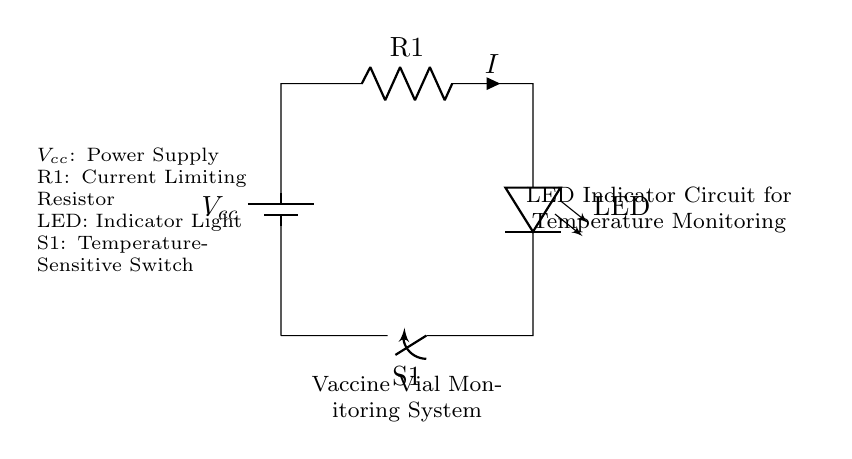What is the main function of the LED in this circuit? The LED serves as an indicator light to show the status of the vaccine vial monitoring system. When activated, it indicates that the system is operational or that certain conditions have been met, such as acceptable temperature ranges.
Answer: Indicator light What does R1 represent in the circuit? R1 is a current limiting resistor that is used to control the amount of current flowing through the LED, preventing it from burning out. Its presence is crucial in ensuring the LED operates safely within its specified limits.
Answer: Current limiting resistor How does the temperature-sensitive switch S1 operate in this circuit? S1 is designed to close or open based on temperature changes. If the temperature goes above or below a specified threshold, S1 will either allow or stop current flow to the LED, indicating whether the conditions are acceptable for the vaccine storage.
Answer: Control current flow What is the purpose of the battery in this configuration? The battery, labeled as Vcc, provides the necessary voltage supply to the circuit, allowing components like the LED and switch to function effectively. It is essential for powering the entire monitoring system.
Answer: Power supply What is the current flowing through the resistor R1 when the switch S1 is closed? When S1 is closed and the circuit is complete, the current indicated as I flows through R1 and the LED. The amount of current depends on the value of R1 and the voltage supplied by Vcc, following Ohm’s law.
Answer: I What might happen if S1 fails to operate correctly? If S1 fails to function, the LED may either remain always on or never turn on, which would compromise the vaccine monitoring system's effectiveness, failing to signal if the temperature conditions are unsafe.
Answer: Compromise monitoring 